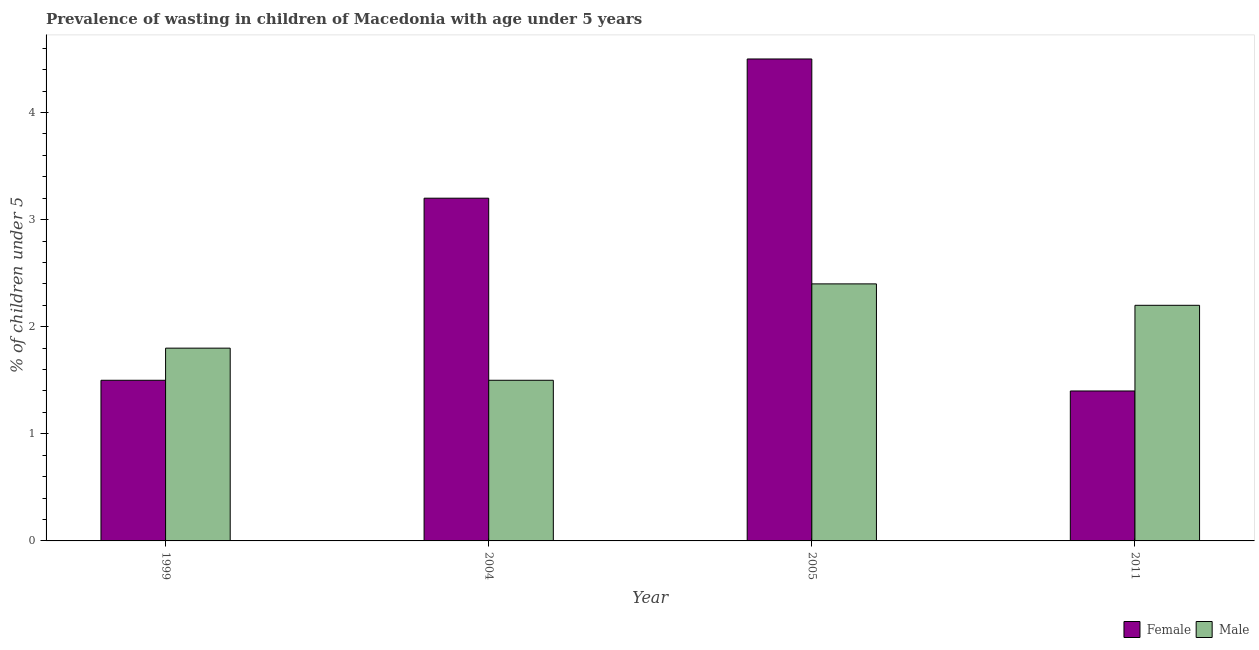How many different coloured bars are there?
Give a very brief answer. 2. How many groups of bars are there?
Ensure brevity in your answer.  4. What is the label of the 2nd group of bars from the left?
Provide a succinct answer. 2004. Across all years, what is the maximum percentage of undernourished female children?
Make the answer very short. 4.5. Across all years, what is the minimum percentage of undernourished male children?
Give a very brief answer. 1.5. In which year was the percentage of undernourished male children maximum?
Give a very brief answer. 2005. What is the total percentage of undernourished male children in the graph?
Provide a short and direct response. 7.9. What is the difference between the percentage of undernourished male children in 1999 and that in 2004?
Your answer should be compact. 0.3. What is the difference between the percentage of undernourished male children in 2011 and the percentage of undernourished female children in 1999?
Offer a terse response. 0.4. What is the average percentage of undernourished male children per year?
Make the answer very short. 1.98. In the year 2011, what is the difference between the percentage of undernourished male children and percentage of undernourished female children?
Your response must be concise. 0. What is the ratio of the percentage of undernourished female children in 1999 to that in 2005?
Your answer should be compact. 0.33. Is the difference between the percentage of undernourished male children in 2004 and 2011 greater than the difference between the percentage of undernourished female children in 2004 and 2011?
Provide a short and direct response. No. What is the difference between the highest and the second highest percentage of undernourished male children?
Ensure brevity in your answer.  0.2. What is the difference between the highest and the lowest percentage of undernourished female children?
Provide a succinct answer. 3.1. In how many years, is the percentage of undernourished female children greater than the average percentage of undernourished female children taken over all years?
Your answer should be very brief. 2. How many bars are there?
Your answer should be compact. 8. Are the values on the major ticks of Y-axis written in scientific E-notation?
Make the answer very short. No. Does the graph contain any zero values?
Provide a succinct answer. No. Does the graph contain grids?
Your answer should be very brief. No. Where does the legend appear in the graph?
Your response must be concise. Bottom right. How many legend labels are there?
Offer a very short reply. 2. What is the title of the graph?
Offer a very short reply. Prevalence of wasting in children of Macedonia with age under 5 years. What is the label or title of the Y-axis?
Your answer should be very brief.  % of children under 5. What is the  % of children under 5 in Male in 1999?
Your answer should be very brief. 1.8. What is the  % of children under 5 in Female in 2004?
Your answer should be compact. 3.2. What is the  % of children under 5 of Male in 2004?
Offer a very short reply. 1.5. What is the  % of children under 5 in Male in 2005?
Provide a succinct answer. 2.4. What is the  % of children under 5 of Female in 2011?
Offer a terse response. 1.4. What is the  % of children under 5 of Male in 2011?
Ensure brevity in your answer.  2.2. Across all years, what is the maximum  % of children under 5 of Male?
Ensure brevity in your answer.  2.4. Across all years, what is the minimum  % of children under 5 of Female?
Make the answer very short. 1.4. What is the total  % of children under 5 of Male in the graph?
Your answer should be compact. 7.9. What is the difference between the  % of children under 5 in Female in 1999 and that in 2004?
Give a very brief answer. -1.7. What is the difference between the  % of children under 5 of Female in 1999 and that in 2005?
Offer a terse response. -3. What is the difference between the  % of children under 5 in Male in 1999 and that in 2005?
Provide a short and direct response. -0.6. What is the difference between the  % of children under 5 in Female in 1999 and that in 2011?
Your answer should be very brief. 0.1. What is the difference between the  % of children under 5 of Female in 2004 and that in 2005?
Ensure brevity in your answer.  -1.3. What is the difference between the  % of children under 5 of Female in 2004 and that in 2011?
Offer a terse response. 1.8. What is the difference between the  % of children under 5 of Male in 2005 and that in 2011?
Your answer should be very brief. 0.2. What is the difference between the  % of children under 5 in Female in 1999 and the  % of children under 5 in Male in 2005?
Make the answer very short. -0.9. What is the difference between the  % of children under 5 in Female in 1999 and the  % of children under 5 in Male in 2011?
Your response must be concise. -0.7. What is the average  % of children under 5 in Female per year?
Make the answer very short. 2.65. What is the average  % of children under 5 of Male per year?
Your answer should be very brief. 1.98. In the year 1999, what is the difference between the  % of children under 5 of Female and  % of children under 5 of Male?
Keep it short and to the point. -0.3. In the year 2004, what is the difference between the  % of children under 5 of Female and  % of children under 5 of Male?
Make the answer very short. 1.7. In the year 2005, what is the difference between the  % of children under 5 of Female and  % of children under 5 of Male?
Ensure brevity in your answer.  2.1. In the year 2011, what is the difference between the  % of children under 5 of Female and  % of children under 5 of Male?
Provide a short and direct response. -0.8. What is the ratio of the  % of children under 5 in Female in 1999 to that in 2004?
Give a very brief answer. 0.47. What is the ratio of the  % of children under 5 of Male in 1999 to that in 2005?
Offer a terse response. 0.75. What is the ratio of the  % of children under 5 of Female in 1999 to that in 2011?
Provide a succinct answer. 1.07. What is the ratio of the  % of children under 5 of Male in 1999 to that in 2011?
Offer a very short reply. 0.82. What is the ratio of the  % of children under 5 in Female in 2004 to that in 2005?
Your response must be concise. 0.71. What is the ratio of the  % of children under 5 of Female in 2004 to that in 2011?
Provide a short and direct response. 2.29. What is the ratio of the  % of children under 5 in Male in 2004 to that in 2011?
Offer a terse response. 0.68. What is the ratio of the  % of children under 5 of Female in 2005 to that in 2011?
Your answer should be compact. 3.21. What is the ratio of the  % of children under 5 in Male in 2005 to that in 2011?
Your answer should be very brief. 1.09. What is the difference between the highest and the second highest  % of children under 5 in Female?
Ensure brevity in your answer.  1.3. What is the difference between the highest and the second highest  % of children under 5 in Male?
Offer a very short reply. 0.2. 